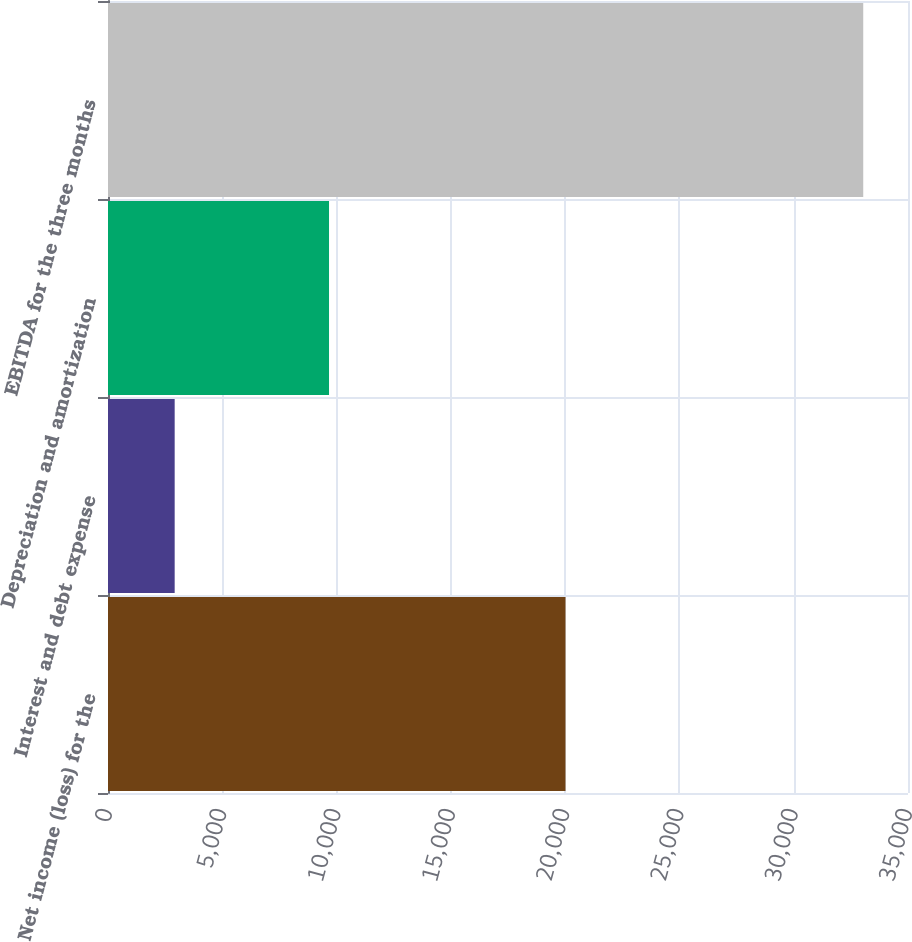Convert chart to OTSL. <chart><loc_0><loc_0><loc_500><loc_500><bar_chart><fcel>Net income (loss) for the<fcel>Interest and debt expense<fcel>Depreciation and amortization<fcel>EBITDA for the three months<nl><fcel>20016<fcel>2917<fcel>9670<fcel>33042<nl></chart> 